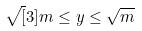Convert formula to latex. <formula><loc_0><loc_0><loc_500><loc_500>\sqrt { [ } 3 ] { m } \leq y \leq \sqrt { m }</formula> 